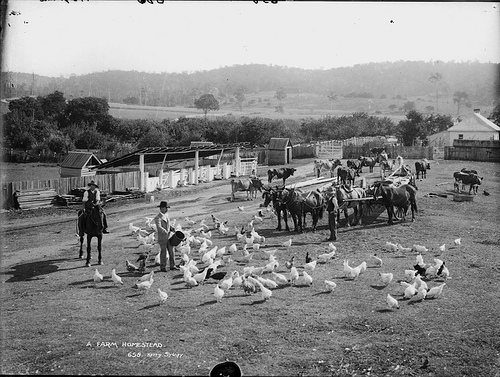What do these birds produce?
Answer the question using a single word or phrase. Egg 